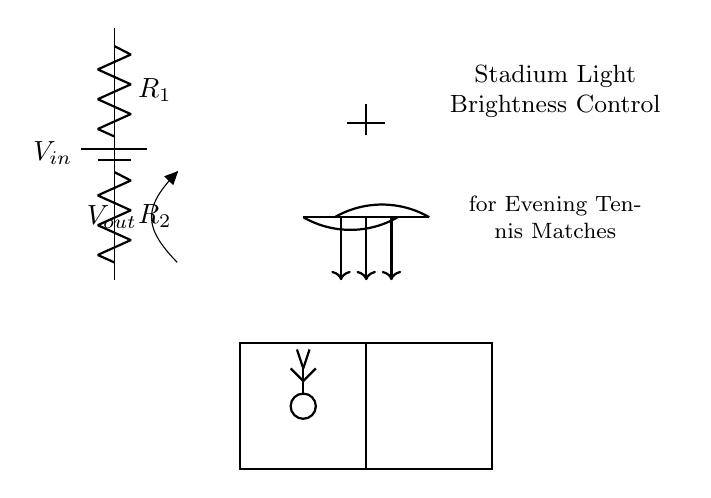What is the input voltage represented in the diagram? The input voltage is labeled as V_in, indicating the voltage supplied to the circuit.
Answer: V_in What are the two resistors in the voltage divider? The two resistors are labeled R_1 and R_2, which are critical components for the voltage division in the circuit.
Answer: R_1 and R_2 What would be adjusted to control the brightness of the stadium lights? The output voltage, V_out, is what gets adjusted to control the brightness of the stadium lights by varying the voltage across them.
Answer: V_out If R_1 is twice the value of R_2, what is the voltage across R_2 compared to V_in? In a voltage divider, if R_1 is twice R_2, the voltage across R_2 (which is V_out) would be one-third of V_in, as per the voltage divider rule.
Answer: One-third of V_in How does increasing R_1 affect V_out? Increasing R_1 while keeping R_2 constant increases the voltage across R_1 and thus reduces V_out, lowering the brightness of the lights.
Answer: V_out decreases What circuit type is used here for adjusting light brightness? This circuit is specifically a voltage divider, used to reduce voltage levels for controlling brightness in devices like stadium lights.
Answer: Voltage divider 